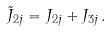<formula> <loc_0><loc_0><loc_500><loc_500>\tilde { J } _ { 2 j } = J _ { 2 j } + J _ { 3 j } \, .</formula> 